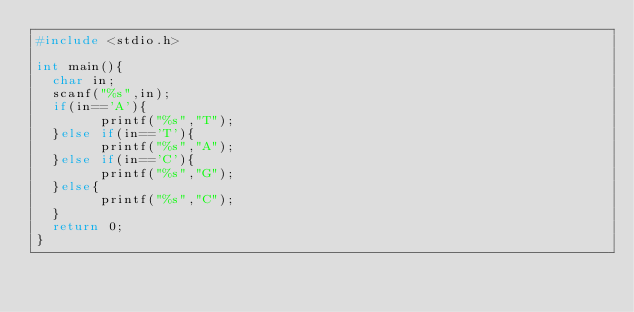Convert code to text. <code><loc_0><loc_0><loc_500><loc_500><_C_>#include <stdio.h>

int main(){
  char in;
  scanf("%s",in);
  if(in=='A'){
    	printf("%s","T");
  }else if(in=='T'){
    	printf("%s","A");
  }else if(in=='C'){
    	printf("%s","G");
  }else{
    	printf("%s","C");
  }
  return 0;
}
</code> 